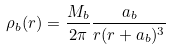Convert formula to latex. <formula><loc_0><loc_0><loc_500><loc_500>\rho _ { b } ( r ) = \frac { M _ { b } } { 2 \pi } \frac { a _ { b } } { r ( r + a _ { b } ) ^ { 3 } }</formula> 